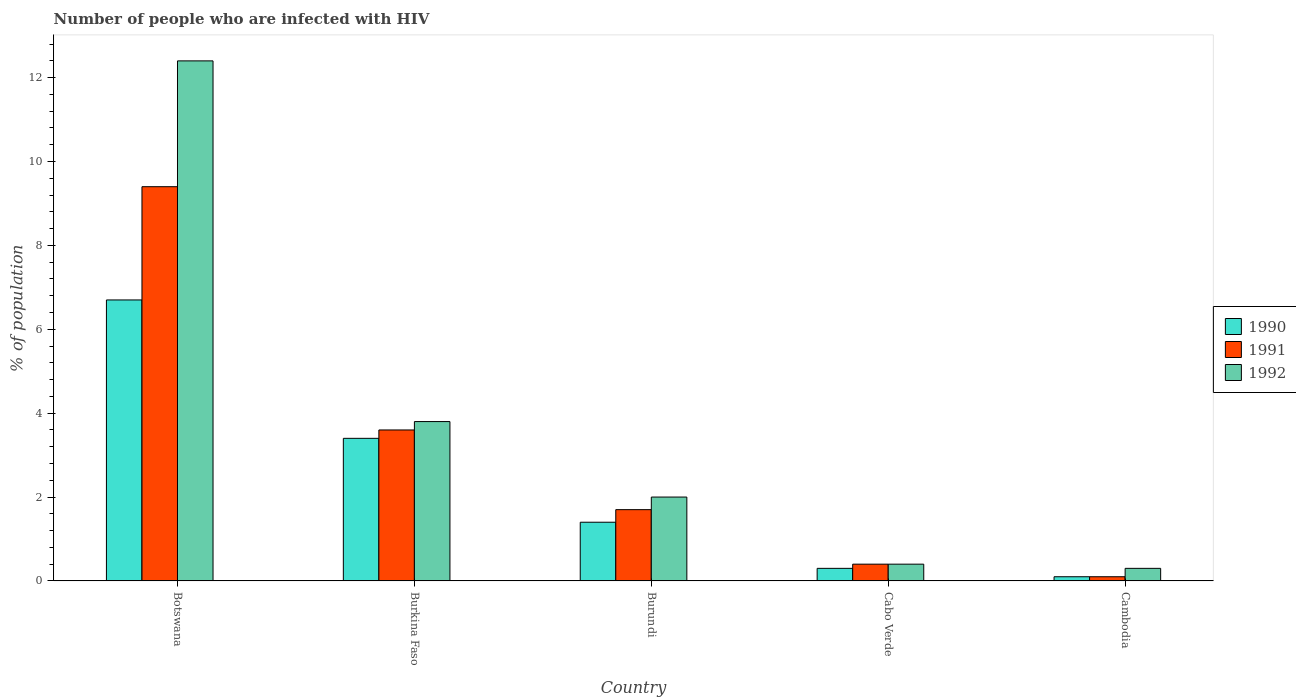How many different coloured bars are there?
Offer a terse response. 3. Are the number of bars on each tick of the X-axis equal?
Your answer should be compact. Yes. How many bars are there on the 1st tick from the right?
Your response must be concise. 3. What is the label of the 1st group of bars from the left?
Your answer should be compact. Botswana. What is the percentage of HIV infected population in in 1992 in Cambodia?
Ensure brevity in your answer.  0.3. Across all countries, what is the maximum percentage of HIV infected population in in 1992?
Offer a terse response. 12.4. Across all countries, what is the minimum percentage of HIV infected population in in 1991?
Ensure brevity in your answer.  0.1. In which country was the percentage of HIV infected population in in 1990 maximum?
Your response must be concise. Botswana. In which country was the percentage of HIV infected population in in 1992 minimum?
Keep it short and to the point. Cambodia. What is the total percentage of HIV infected population in in 1991 in the graph?
Provide a short and direct response. 15.2. What is the difference between the percentage of HIV infected population in in 1992 in Burundi and that in Cambodia?
Your answer should be compact. 1.7. What is the difference between the percentage of HIV infected population in in 1990 in Burkina Faso and the percentage of HIV infected population in in 1992 in Cambodia?
Your response must be concise. 3.1. What is the average percentage of HIV infected population in in 1992 per country?
Keep it short and to the point. 3.78. What is the difference between the percentage of HIV infected population in of/in 1991 and percentage of HIV infected population in of/in 1990 in Cambodia?
Provide a succinct answer. 0. In how many countries, is the percentage of HIV infected population in in 1992 greater than 7.6 %?
Your answer should be compact. 1. What is the ratio of the percentage of HIV infected population in in 1990 in Burundi to that in Cabo Verde?
Give a very brief answer. 4.67. Is the percentage of HIV infected population in in 1990 in Cabo Verde less than that in Cambodia?
Keep it short and to the point. No. Is the difference between the percentage of HIV infected population in in 1991 in Burundi and Cambodia greater than the difference between the percentage of HIV infected population in in 1990 in Burundi and Cambodia?
Give a very brief answer. Yes. What is the difference between the highest and the second highest percentage of HIV infected population in in 1992?
Ensure brevity in your answer.  -1.8. What is the difference between the highest and the lowest percentage of HIV infected population in in 1990?
Provide a short and direct response. 6.6. Is the sum of the percentage of HIV infected population in in 1991 in Botswana and Cabo Verde greater than the maximum percentage of HIV infected population in in 1990 across all countries?
Ensure brevity in your answer.  Yes. Is it the case that in every country, the sum of the percentage of HIV infected population in in 1991 and percentage of HIV infected population in in 1990 is greater than the percentage of HIV infected population in in 1992?
Keep it short and to the point. No. Are the values on the major ticks of Y-axis written in scientific E-notation?
Ensure brevity in your answer.  No. Does the graph contain grids?
Provide a short and direct response. No. How many legend labels are there?
Keep it short and to the point. 3. What is the title of the graph?
Provide a succinct answer. Number of people who are infected with HIV. What is the label or title of the Y-axis?
Make the answer very short. % of population. What is the % of population of 1990 in Botswana?
Keep it short and to the point. 6.7. What is the % of population of 1992 in Burundi?
Ensure brevity in your answer.  2. What is the % of population in 1990 in Cabo Verde?
Keep it short and to the point. 0.3. What is the % of population of 1991 in Cabo Verde?
Ensure brevity in your answer.  0.4. What is the % of population in 1990 in Cambodia?
Your answer should be very brief. 0.1. What is the % of population of 1992 in Cambodia?
Ensure brevity in your answer.  0.3. Across all countries, what is the maximum % of population in 1991?
Provide a short and direct response. 9.4. Across all countries, what is the minimum % of population in 1991?
Make the answer very short. 0.1. Across all countries, what is the minimum % of population of 1992?
Make the answer very short. 0.3. What is the total % of population in 1991 in the graph?
Your answer should be very brief. 15.2. What is the difference between the % of population in 1990 in Botswana and that in Burkina Faso?
Ensure brevity in your answer.  3.3. What is the difference between the % of population in 1992 in Botswana and that in Burkina Faso?
Your answer should be very brief. 8.6. What is the difference between the % of population of 1990 in Botswana and that in Burundi?
Give a very brief answer. 5.3. What is the difference between the % of population in 1991 in Botswana and that in Burundi?
Keep it short and to the point. 7.7. What is the difference between the % of population of 1992 in Botswana and that in Burundi?
Your answer should be compact. 10.4. What is the difference between the % of population of 1990 in Botswana and that in Cabo Verde?
Provide a short and direct response. 6.4. What is the difference between the % of population of 1990 in Botswana and that in Cambodia?
Your answer should be very brief. 6.6. What is the difference between the % of population of 1991 in Burkina Faso and that in Burundi?
Your answer should be very brief. 1.9. What is the difference between the % of population in 1991 in Burkina Faso and that in Cabo Verde?
Offer a very short reply. 3.2. What is the difference between the % of population in 1992 in Burkina Faso and that in Cabo Verde?
Give a very brief answer. 3.4. What is the difference between the % of population of 1990 in Burkina Faso and that in Cambodia?
Provide a succinct answer. 3.3. What is the difference between the % of population in 1990 in Burundi and that in Cabo Verde?
Offer a very short reply. 1.1. What is the difference between the % of population of 1990 in Burundi and that in Cambodia?
Offer a very short reply. 1.3. What is the difference between the % of population in 1991 in Burundi and that in Cambodia?
Your answer should be compact. 1.6. What is the difference between the % of population in 1992 in Cabo Verde and that in Cambodia?
Your answer should be very brief. 0.1. What is the difference between the % of population in 1990 in Botswana and the % of population in 1992 in Burundi?
Provide a succinct answer. 4.7. What is the difference between the % of population in 1990 in Botswana and the % of population in 1992 in Cambodia?
Your answer should be very brief. 6.4. What is the difference between the % of population of 1991 in Botswana and the % of population of 1992 in Cambodia?
Provide a succinct answer. 9.1. What is the difference between the % of population of 1990 in Burkina Faso and the % of population of 1991 in Burundi?
Your answer should be compact. 1.7. What is the difference between the % of population in 1990 in Burkina Faso and the % of population in 1992 in Burundi?
Provide a short and direct response. 1.4. What is the difference between the % of population of 1991 in Burkina Faso and the % of population of 1992 in Burundi?
Your response must be concise. 1.6. What is the difference between the % of population of 1990 in Burkina Faso and the % of population of 1991 in Cabo Verde?
Offer a very short reply. 3. What is the difference between the % of population in 1990 in Burkina Faso and the % of population in 1992 in Cabo Verde?
Make the answer very short. 3. What is the difference between the % of population in 1990 in Burkina Faso and the % of population in 1991 in Cambodia?
Give a very brief answer. 3.3. What is the difference between the % of population in 1990 in Burkina Faso and the % of population in 1992 in Cambodia?
Your answer should be compact. 3.1. What is the difference between the % of population in 1991 in Burkina Faso and the % of population in 1992 in Cambodia?
Offer a very short reply. 3.3. What is the difference between the % of population in 1990 in Burundi and the % of population in 1991 in Cabo Verde?
Provide a short and direct response. 1. What is the difference between the % of population of 1990 in Burundi and the % of population of 1992 in Cabo Verde?
Offer a very short reply. 1. What is the difference between the % of population in 1991 in Burundi and the % of population in 1992 in Cabo Verde?
Your answer should be very brief. 1.3. What is the difference between the % of population in 1990 in Burundi and the % of population in 1991 in Cambodia?
Provide a short and direct response. 1.3. What is the difference between the % of population in 1991 in Burundi and the % of population in 1992 in Cambodia?
Make the answer very short. 1.4. What is the difference between the % of population of 1990 in Cabo Verde and the % of population of 1991 in Cambodia?
Your answer should be compact. 0.2. What is the average % of population of 1990 per country?
Give a very brief answer. 2.38. What is the average % of population of 1991 per country?
Provide a short and direct response. 3.04. What is the average % of population in 1992 per country?
Your response must be concise. 3.78. What is the difference between the % of population in 1990 and % of population in 1991 in Burkina Faso?
Your answer should be compact. -0.2. What is the difference between the % of population of 1990 and % of population of 1992 in Burkina Faso?
Provide a short and direct response. -0.4. What is the difference between the % of population in 1991 and % of population in 1992 in Burkina Faso?
Make the answer very short. -0.2. What is the difference between the % of population in 1990 and % of population in 1991 in Burundi?
Provide a short and direct response. -0.3. What is the difference between the % of population in 1990 and % of population in 1991 in Cabo Verde?
Offer a terse response. -0.1. What is the ratio of the % of population of 1990 in Botswana to that in Burkina Faso?
Give a very brief answer. 1.97. What is the ratio of the % of population in 1991 in Botswana to that in Burkina Faso?
Ensure brevity in your answer.  2.61. What is the ratio of the % of population of 1992 in Botswana to that in Burkina Faso?
Ensure brevity in your answer.  3.26. What is the ratio of the % of population in 1990 in Botswana to that in Burundi?
Your response must be concise. 4.79. What is the ratio of the % of population of 1991 in Botswana to that in Burundi?
Your answer should be compact. 5.53. What is the ratio of the % of population of 1990 in Botswana to that in Cabo Verde?
Keep it short and to the point. 22.33. What is the ratio of the % of population of 1992 in Botswana to that in Cabo Verde?
Your answer should be very brief. 31. What is the ratio of the % of population of 1991 in Botswana to that in Cambodia?
Ensure brevity in your answer.  94. What is the ratio of the % of population in 1992 in Botswana to that in Cambodia?
Your answer should be compact. 41.33. What is the ratio of the % of population of 1990 in Burkina Faso to that in Burundi?
Provide a short and direct response. 2.43. What is the ratio of the % of population in 1991 in Burkina Faso to that in Burundi?
Give a very brief answer. 2.12. What is the ratio of the % of population in 1992 in Burkina Faso to that in Burundi?
Offer a very short reply. 1.9. What is the ratio of the % of population of 1990 in Burkina Faso to that in Cabo Verde?
Provide a succinct answer. 11.33. What is the ratio of the % of population in 1992 in Burkina Faso to that in Cabo Verde?
Your response must be concise. 9.5. What is the ratio of the % of population in 1991 in Burkina Faso to that in Cambodia?
Your answer should be compact. 36. What is the ratio of the % of population in 1992 in Burkina Faso to that in Cambodia?
Give a very brief answer. 12.67. What is the ratio of the % of population of 1990 in Burundi to that in Cabo Verde?
Give a very brief answer. 4.67. What is the ratio of the % of population in 1991 in Burundi to that in Cabo Verde?
Offer a terse response. 4.25. What is the ratio of the % of population of 1992 in Burundi to that in Cabo Verde?
Give a very brief answer. 5. What is the ratio of the % of population in 1990 in Burundi to that in Cambodia?
Keep it short and to the point. 14. What is the ratio of the % of population in 1991 in Burundi to that in Cambodia?
Provide a succinct answer. 17. What is the ratio of the % of population in 1992 in Burundi to that in Cambodia?
Your answer should be compact. 6.67. What is the ratio of the % of population of 1990 in Cabo Verde to that in Cambodia?
Offer a terse response. 3. What is the ratio of the % of population in 1991 in Cabo Verde to that in Cambodia?
Keep it short and to the point. 4. What is the difference between the highest and the second highest % of population of 1990?
Give a very brief answer. 3.3. What is the difference between the highest and the second highest % of population of 1991?
Give a very brief answer. 5.8. What is the difference between the highest and the second highest % of population in 1992?
Offer a very short reply. 8.6. What is the difference between the highest and the lowest % of population in 1990?
Offer a terse response. 6.6. What is the difference between the highest and the lowest % of population in 1991?
Your answer should be compact. 9.3. 